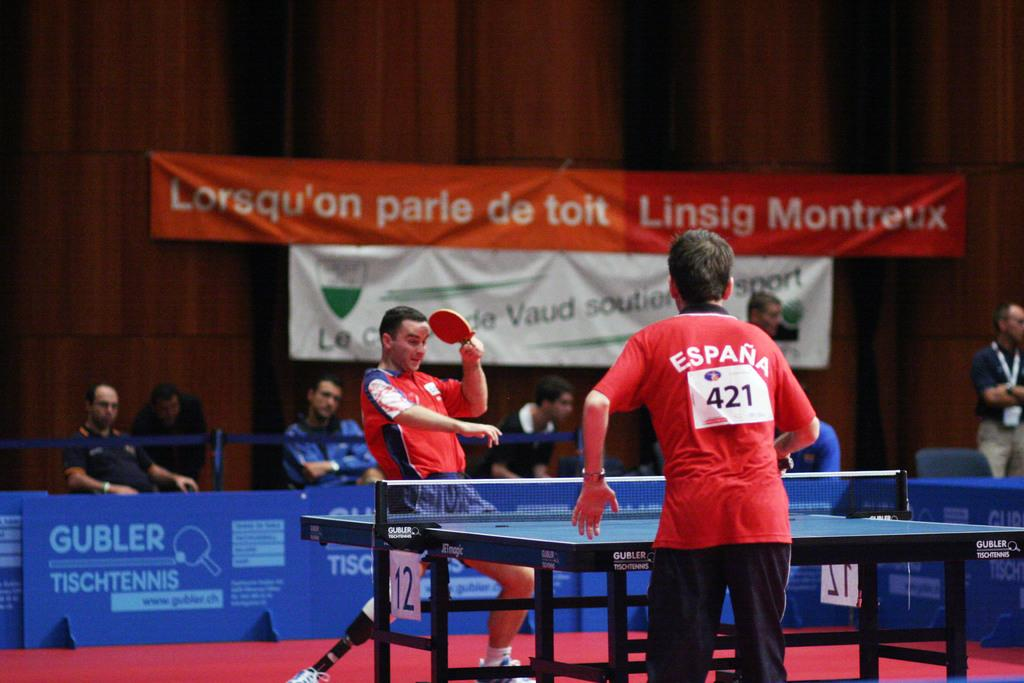<image>
Relay a brief, clear account of the picture shown. A man playing table tennis is wearing a Spain shirt with number 421 on it. 